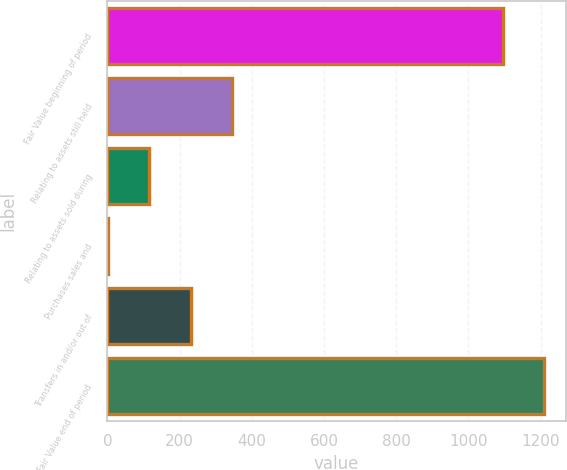<chart> <loc_0><loc_0><loc_500><loc_500><bar_chart><fcel>Fair Value beginning of period<fcel>Relating to assets still held<fcel>Relating to assets sold during<fcel>Purchases sales and<fcel>Transfers in and/or out of<fcel>Fair Value end of period<nl><fcel>1095<fcel>344.78<fcel>116.44<fcel>2.27<fcel>230.61<fcel>1209.17<nl></chart> 